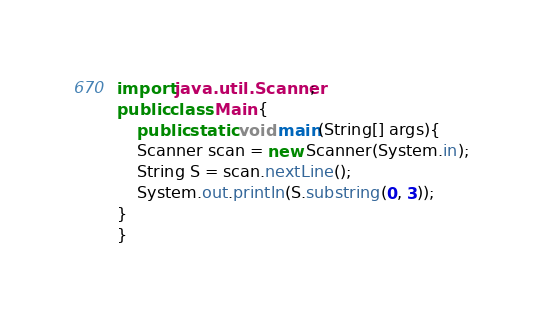<code> <loc_0><loc_0><loc_500><loc_500><_Java_>import java.util.Scanner;
public class Main {
    public static void main(String[] args){
    Scanner scan = new Scanner(System.in);
    String S = scan.nextLine();
    System.out.println(S.substring(0, 3));
}
}</code> 